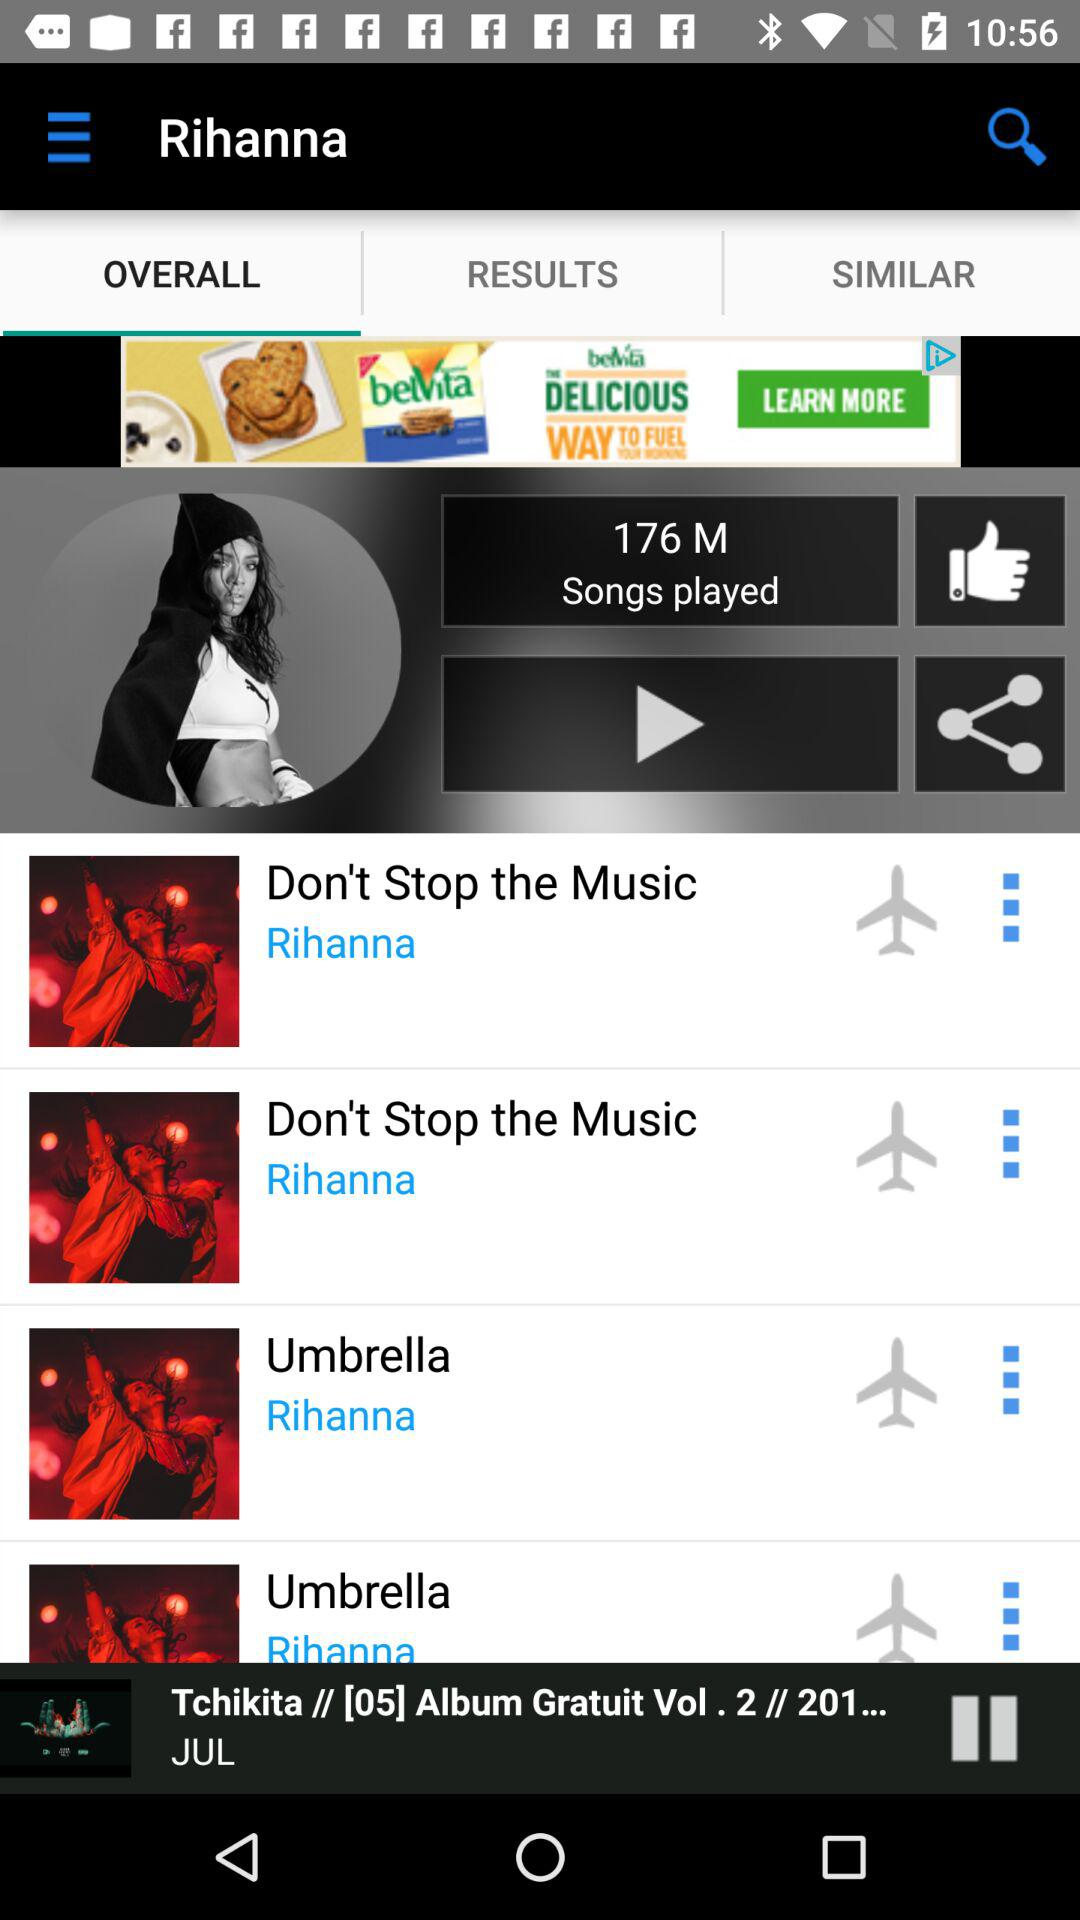How many songs have the title 'Umbrella'?
Answer the question using a single word or phrase. 2 